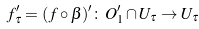Convert formula to latex. <formula><loc_0><loc_0><loc_500><loc_500>f _ { \tau } ^ { \prime } = ( f \circ \beta ) ^ { \prime } \colon O _ { 1 } ^ { \prime } \cap U _ { \tau } \to U _ { \tau }</formula> 